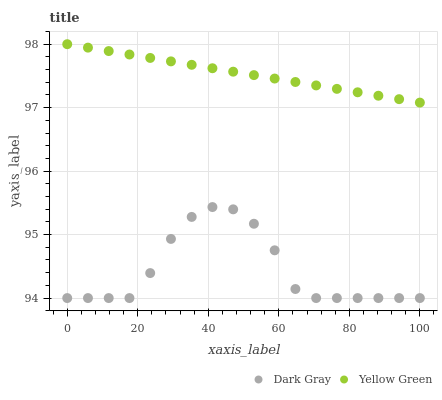Does Dark Gray have the minimum area under the curve?
Answer yes or no. Yes. Does Yellow Green have the maximum area under the curve?
Answer yes or no. Yes. Does Yellow Green have the minimum area under the curve?
Answer yes or no. No. Is Yellow Green the smoothest?
Answer yes or no. Yes. Is Dark Gray the roughest?
Answer yes or no. Yes. Is Yellow Green the roughest?
Answer yes or no. No. Does Dark Gray have the lowest value?
Answer yes or no. Yes. Does Yellow Green have the lowest value?
Answer yes or no. No. Does Yellow Green have the highest value?
Answer yes or no. Yes. Is Dark Gray less than Yellow Green?
Answer yes or no. Yes. Is Yellow Green greater than Dark Gray?
Answer yes or no. Yes. Does Dark Gray intersect Yellow Green?
Answer yes or no. No. 